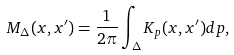<formula> <loc_0><loc_0><loc_500><loc_500>M _ { \Delta } ( x , x ^ { \prime } ) = \frac { 1 } { 2 \pi } \int _ { \Delta } K _ { p } ( x , x ^ { \prime } ) d p ,</formula> 